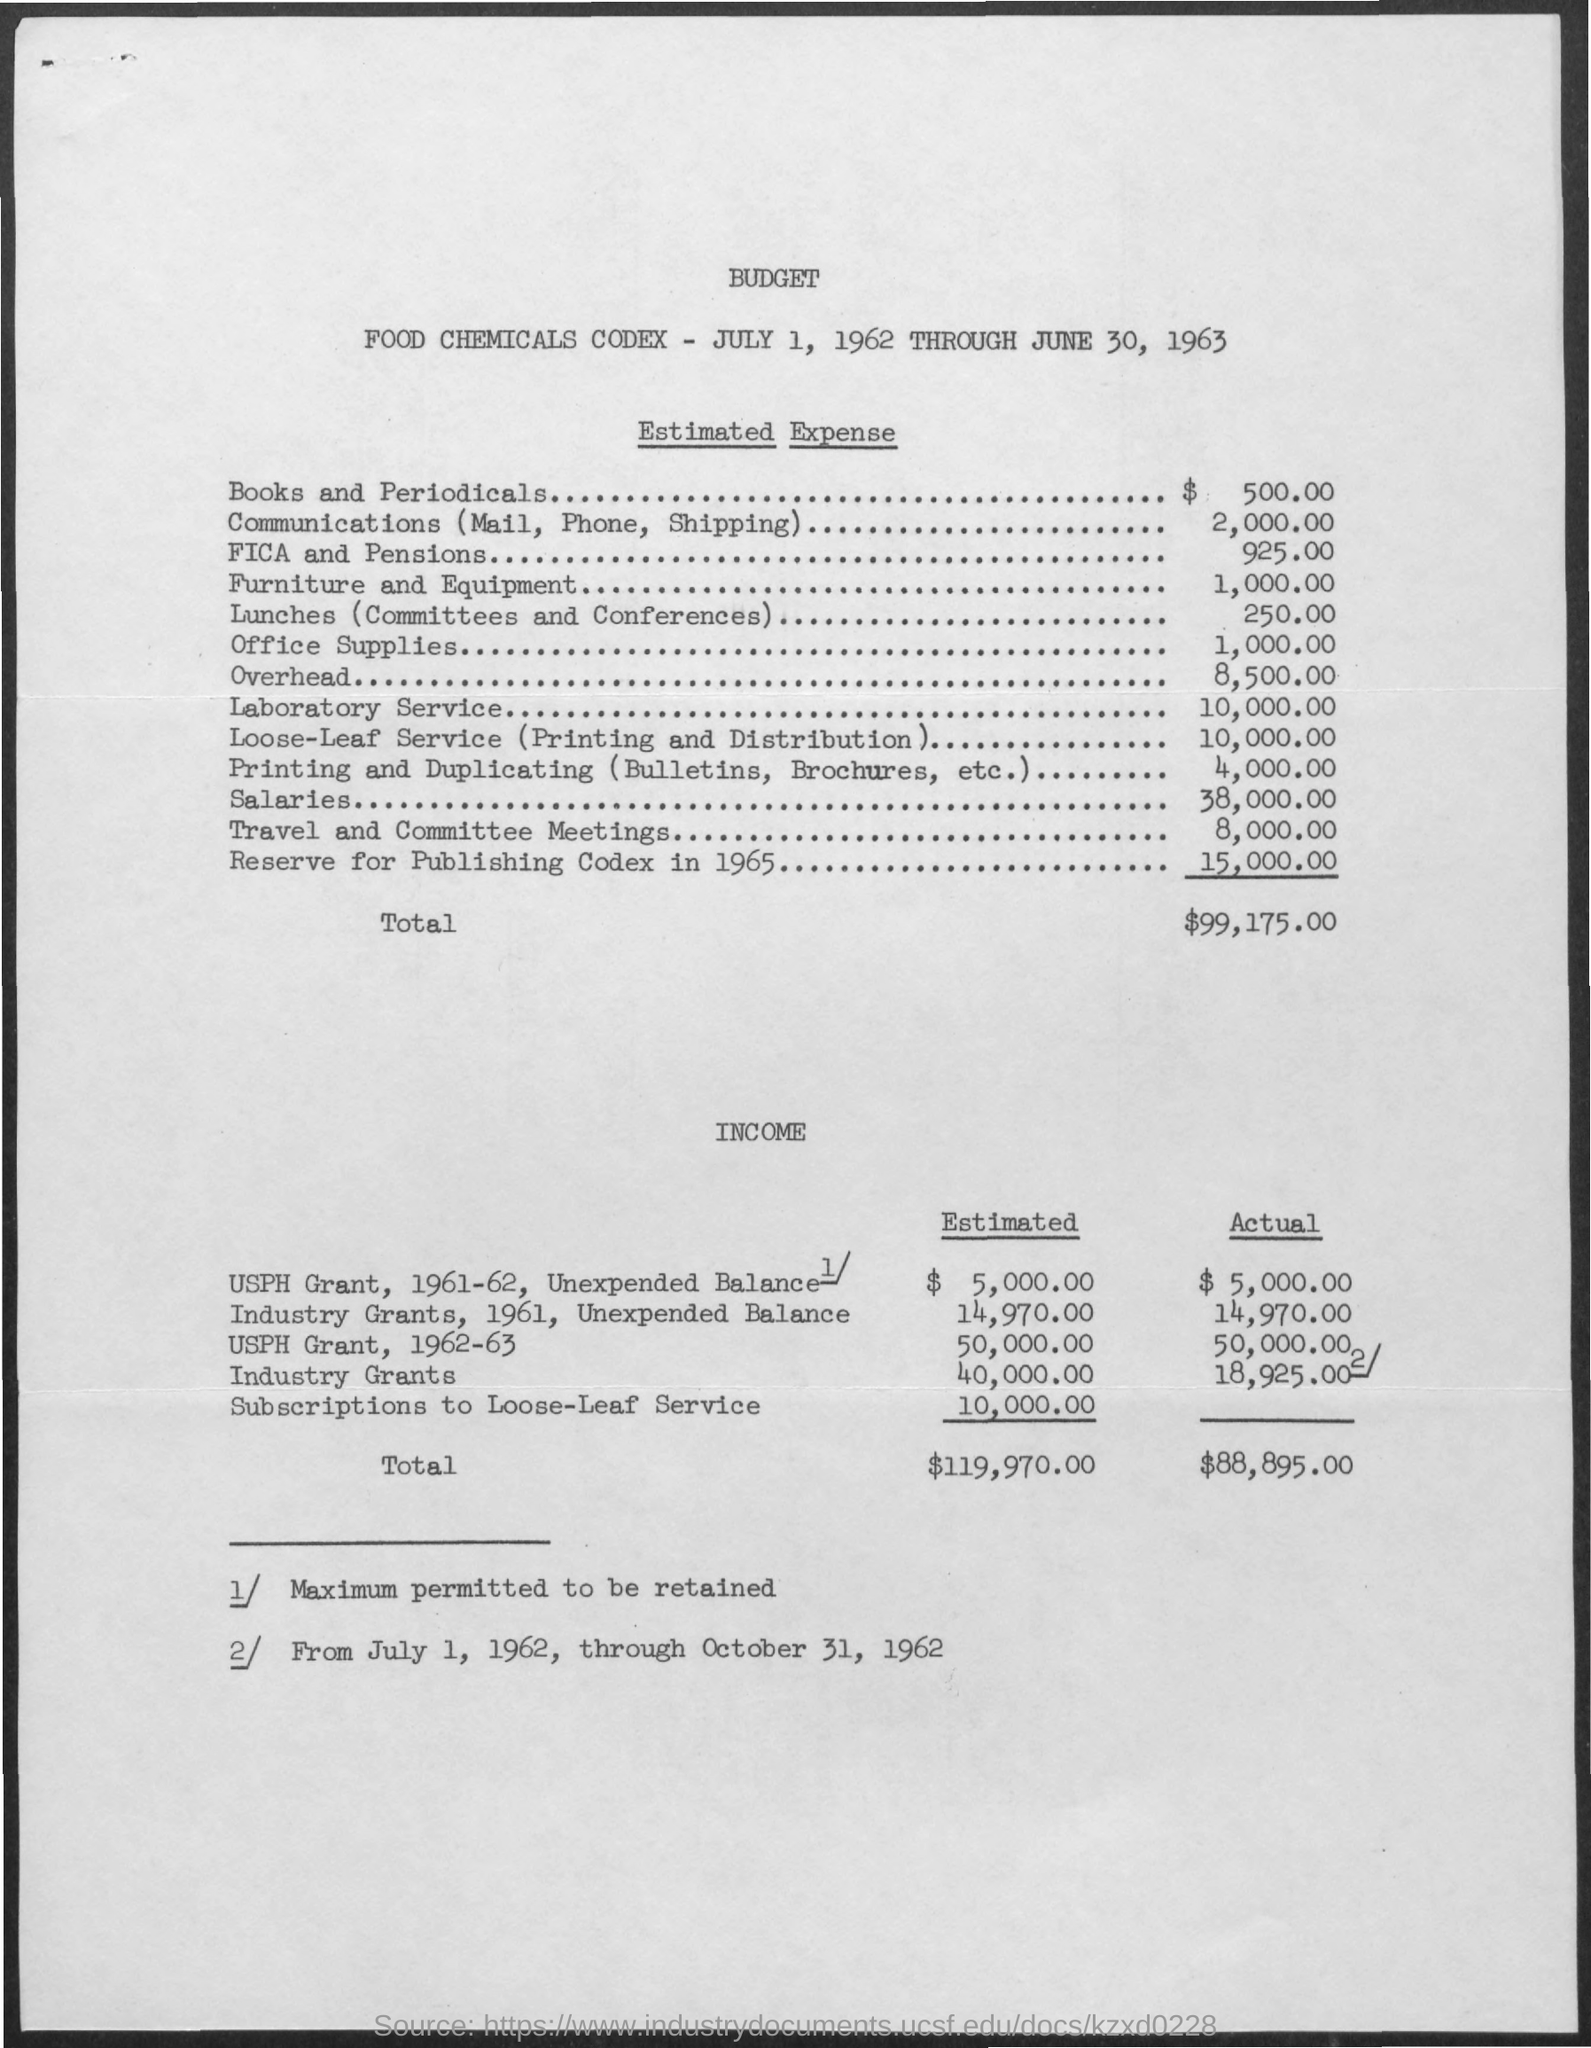What is the tenure of the budget?
Keep it short and to the point. July 1, 1962 through June 30, 1963. 